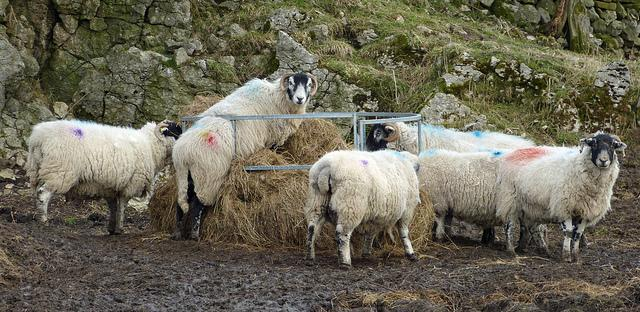What are all of the sheep gathering around in their field? Please explain your reasoning. hay. The sheep are eating the hay. 